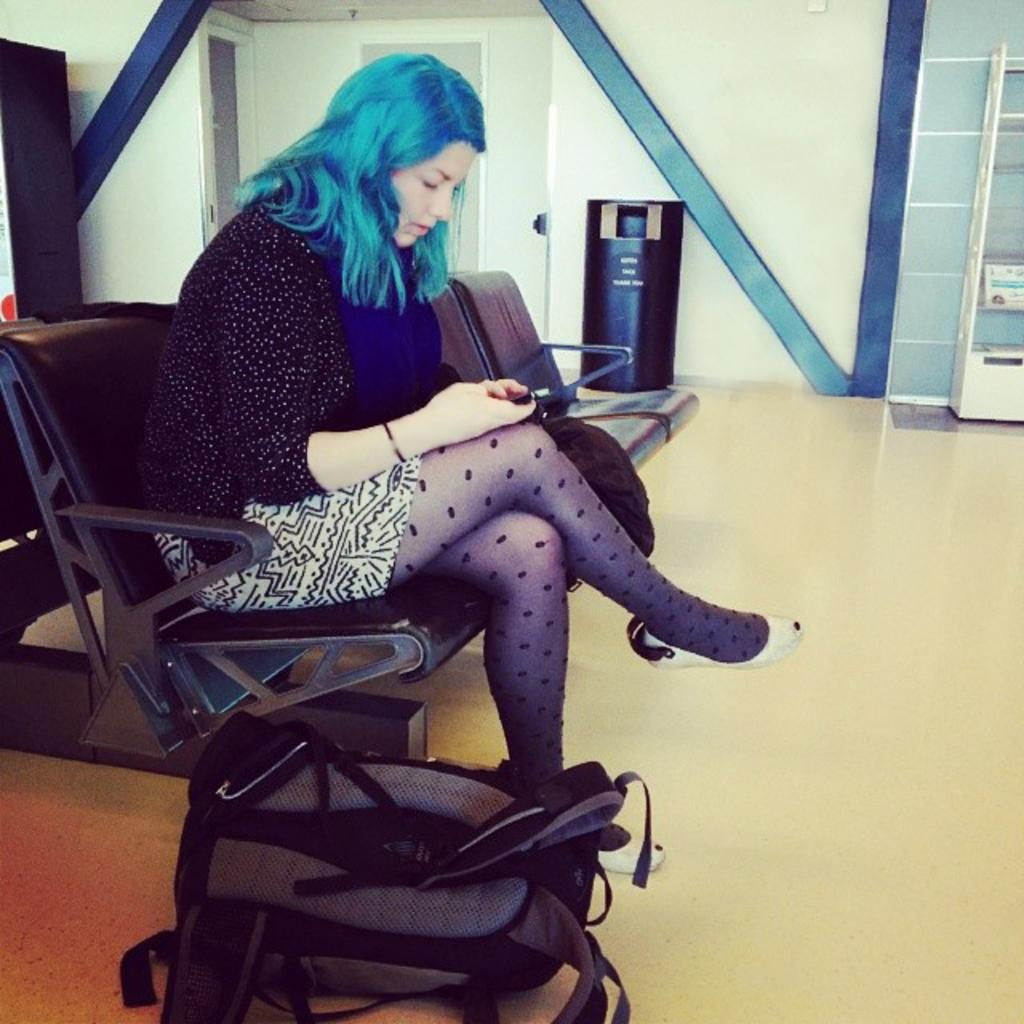Who is the main subject in the image? There is a lady in the image. What is the lady doing in the image? The lady is sitting on a chair. What object is the lady holding in the image? The lady is holding a mobile phone. Can you identify any other objects in the image? Yes, there is a bag present in the image. What type of poison is the lady using to communicate with her friends in the image? There is no poison present in the image; the lady is using a mobile phone to communicate. 